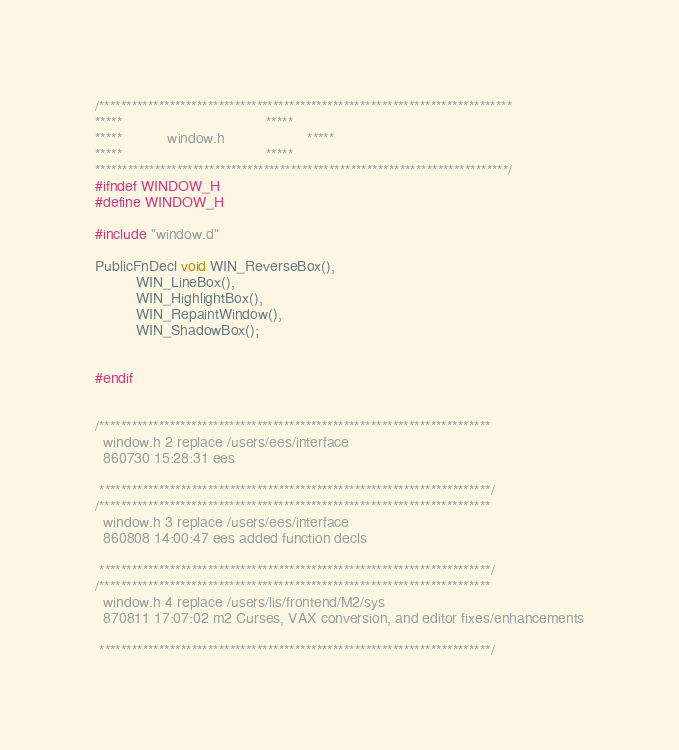<code> <loc_0><loc_0><loc_500><loc_500><_C_>/****************************************************************************
*****									*****
*****			window.h					*****
*****									*****
****************************************************************************/
#ifndef WINDOW_H
#define WINDOW_H

#include "window.d"

PublicFnDecl void WIN_ReverseBox(), 
		  WIN_LineBox(),
		  WIN_HighlightBox(),
		  WIN_RepaintWindow(),
		  WIN_ShadowBox();
		  

#endif


/************************************************************************
  window.h 2 replace /users/ees/interface
  860730 15:28:31 ees  

 ************************************************************************/
/************************************************************************
  window.h 3 replace /users/ees/interface
  860808 14:00:47 ees added function decls

 ************************************************************************/
/************************************************************************
  window.h 4 replace /users/lis/frontend/M2/sys
  870811 17:07:02 m2 Curses, VAX conversion, and editor fixes/enhancements

 ************************************************************************/
</code> 